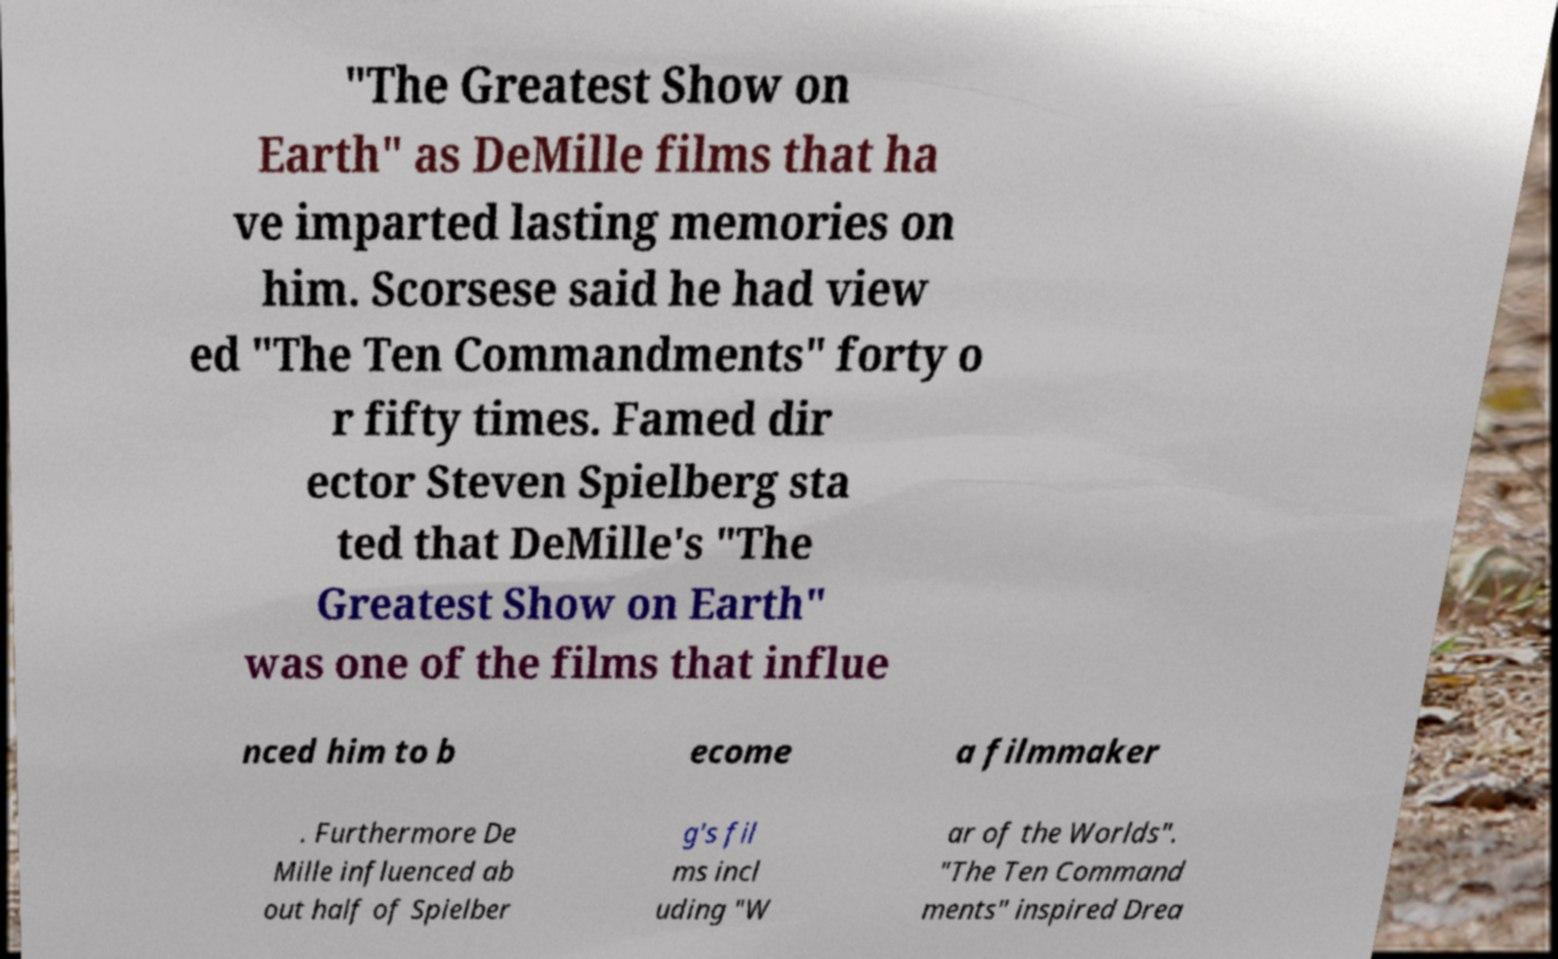There's text embedded in this image that I need extracted. Can you transcribe it verbatim? "The Greatest Show on Earth" as DeMille films that ha ve imparted lasting memories on him. Scorsese said he had view ed "The Ten Commandments" forty o r fifty times. Famed dir ector Steven Spielberg sta ted that DeMille's "The Greatest Show on Earth" was one of the films that influe nced him to b ecome a filmmaker . Furthermore De Mille influenced ab out half of Spielber g's fil ms incl uding "W ar of the Worlds". "The Ten Command ments" inspired Drea 